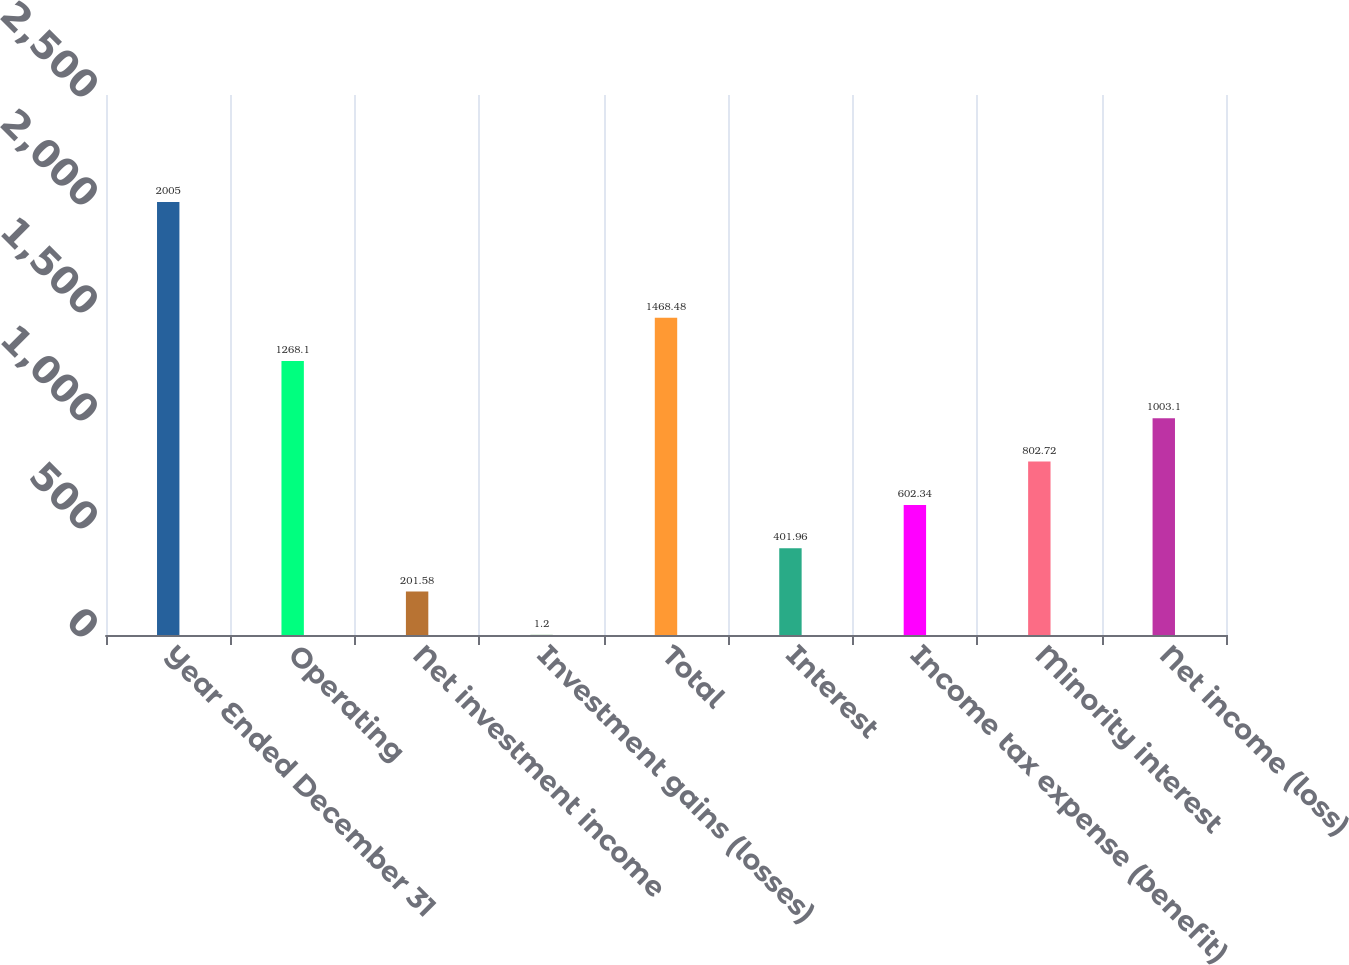<chart> <loc_0><loc_0><loc_500><loc_500><bar_chart><fcel>Year Ended December 31<fcel>Operating<fcel>Net investment income<fcel>Investment gains (losses)<fcel>Total<fcel>Interest<fcel>Income tax expense (benefit)<fcel>Minority interest<fcel>Net income (loss)<nl><fcel>2005<fcel>1268.1<fcel>201.58<fcel>1.2<fcel>1468.48<fcel>401.96<fcel>602.34<fcel>802.72<fcel>1003.1<nl></chart> 